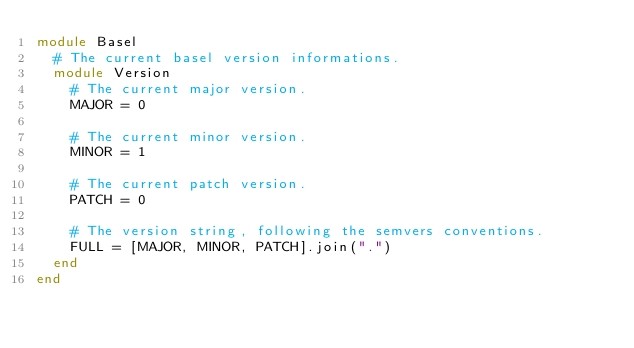Convert code to text. <code><loc_0><loc_0><loc_500><loc_500><_Ruby_>module Basel
  # The current basel version informations.
  module Version
    # The current major version.
    MAJOR = 0

    # The current minor version.
    MINOR = 1

    # The current patch version.
    PATCH = 0

    # The version string, following the semvers conventions.
    FULL = [MAJOR, MINOR, PATCH].join(".")
  end
end
</code> 